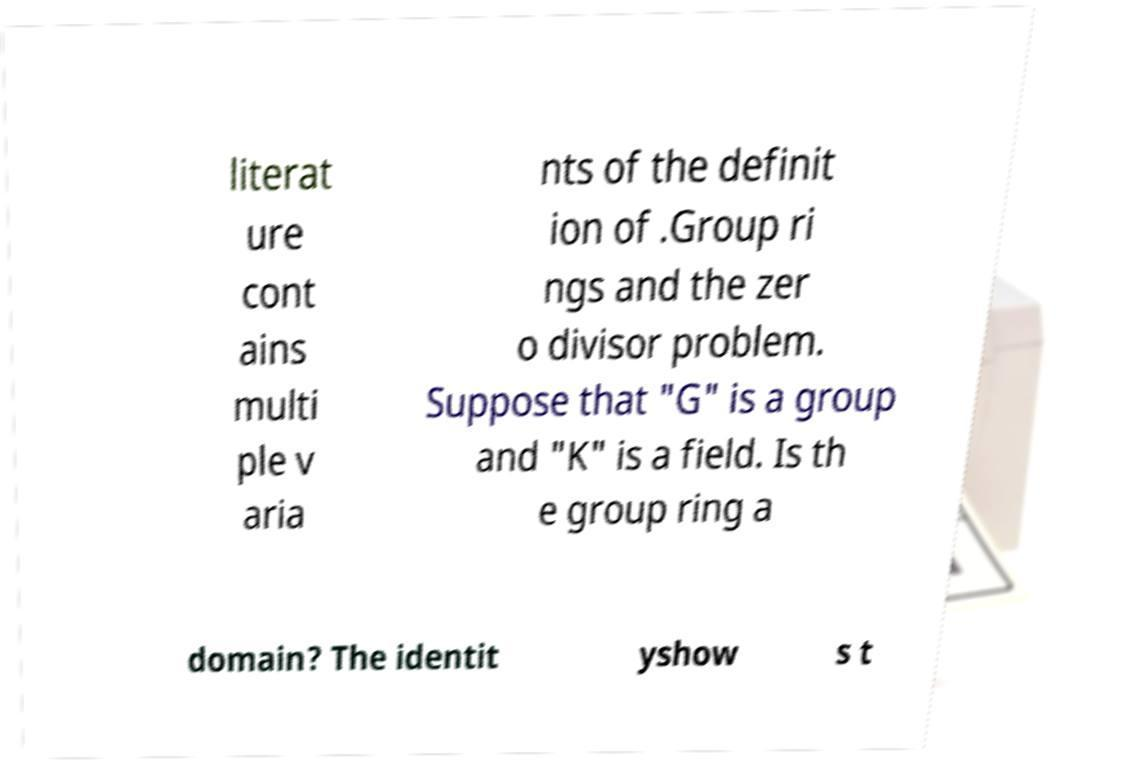Can you read and provide the text displayed in the image?This photo seems to have some interesting text. Can you extract and type it out for me? literat ure cont ains multi ple v aria nts of the definit ion of .Group ri ngs and the zer o divisor problem. Suppose that "G" is a group and "K" is a field. Is th e group ring a domain? The identit yshow s t 